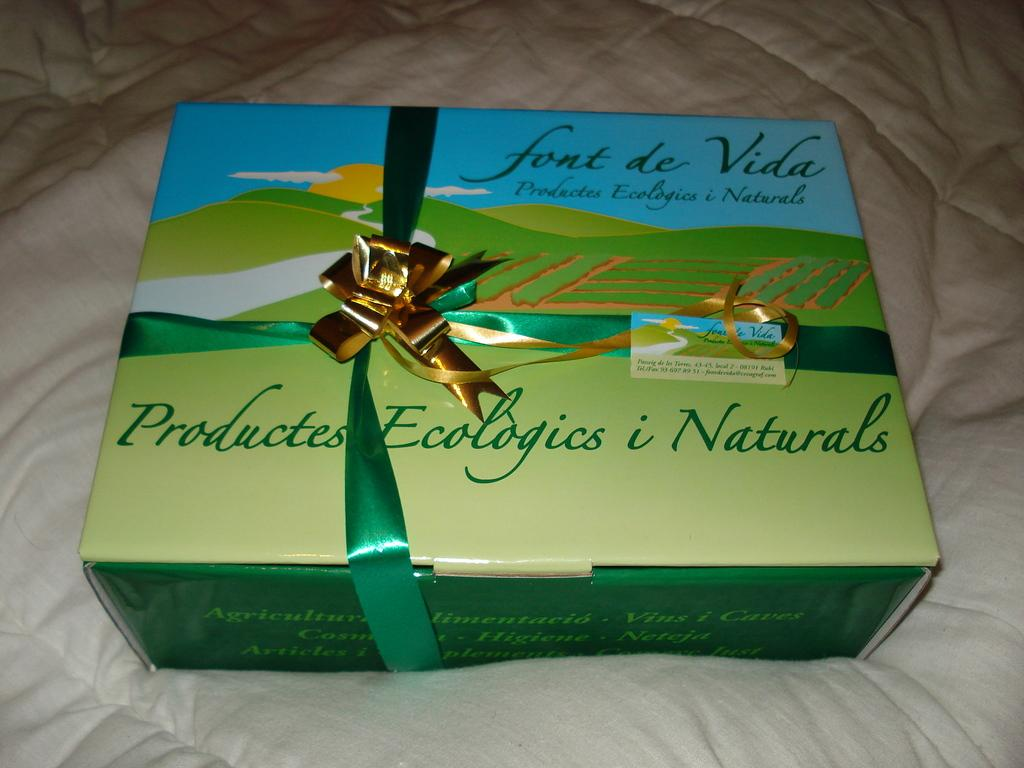<image>
Share a concise interpretation of the image provided. Product of Ecologic and natural source of chocolate. 